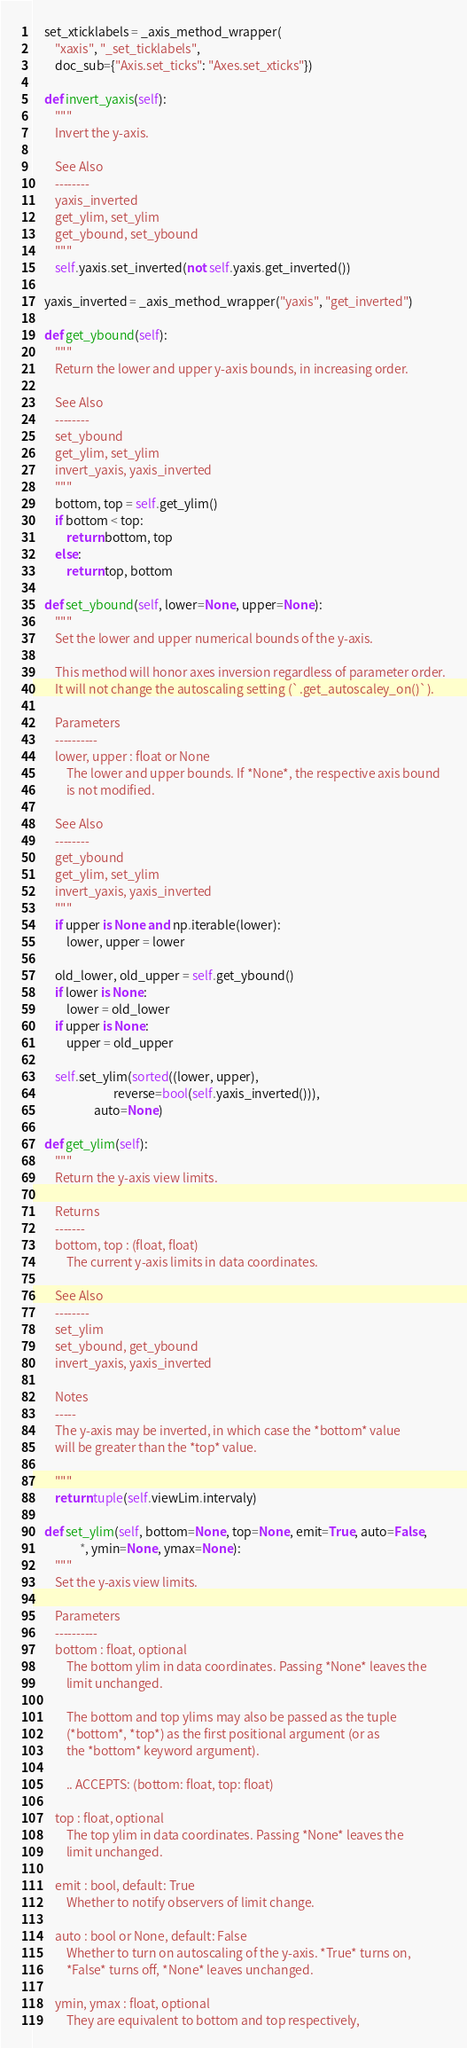<code> <loc_0><loc_0><loc_500><loc_500><_Python_>    set_xticklabels = _axis_method_wrapper(
        "xaxis", "_set_ticklabels",
        doc_sub={"Axis.set_ticks": "Axes.set_xticks"})

    def invert_yaxis(self):
        """
        Invert the y-axis.

        See Also
        --------
        yaxis_inverted
        get_ylim, set_ylim
        get_ybound, set_ybound
        """
        self.yaxis.set_inverted(not self.yaxis.get_inverted())

    yaxis_inverted = _axis_method_wrapper("yaxis", "get_inverted")

    def get_ybound(self):
        """
        Return the lower and upper y-axis bounds, in increasing order.

        See Also
        --------
        set_ybound
        get_ylim, set_ylim
        invert_yaxis, yaxis_inverted
        """
        bottom, top = self.get_ylim()
        if bottom < top:
            return bottom, top
        else:
            return top, bottom

    def set_ybound(self, lower=None, upper=None):
        """
        Set the lower and upper numerical bounds of the y-axis.

        This method will honor axes inversion regardless of parameter order.
        It will not change the autoscaling setting (`.get_autoscaley_on()`).

        Parameters
        ----------
        lower, upper : float or None
            The lower and upper bounds. If *None*, the respective axis bound
            is not modified.

        See Also
        --------
        get_ybound
        get_ylim, set_ylim
        invert_yaxis, yaxis_inverted
        """
        if upper is None and np.iterable(lower):
            lower, upper = lower

        old_lower, old_upper = self.get_ybound()
        if lower is None:
            lower = old_lower
        if upper is None:
            upper = old_upper

        self.set_ylim(sorted((lower, upper),
                             reverse=bool(self.yaxis_inverted())),
                      auto=None)

    def get_ylim(self):
        """
        Return the y-axis view limits.

        Returns
        -------
        bottom, top : (float, float)
            The current y-axis limits in data coordinates.

        See Also
        --------
        set_ylim
        set_ybound, get_ybound
        invert_yaxis, yaxis_inverted

        Notes
        -----
        The y-axis may be inverted, in which case the *bottom* value
        will be greater than the *top* value.

        """
        return tuple(self.viewLim.intervaly)

    def set_ylim(self, bottom=None, top=None, emit=True, auto=False,
                 *, ymin=None, ymax=None):
        """
        Set the y-axis view limits.

        Parameters
        ----------
        bottom : float, optional
            The bottom ylim in data coordinates. Passing *None* leaves the
            limit unchanged.

            The bottom and top ylims may also be passed as the tuple
            (*bottom*, *top*) as the first positional argument (or as
            the *bottom* keyword argument).

            .. ACCEPTS: (bottom: float, top: float)

        top : float, optional
            The top ylim in data coordinates. Passing *None* leaves the
            limit unchanged.

        emit : bool, default: True
            Whether to notify observers of limit change.

        auto : bool or None, default: False
            Whether to turn on autoscaling of the y-axis. *True* turns on,
            *False* turns off, *None* leaves unchanged.

        ymin, ymax : float, optional
            They are equivalent to bottom and top respectively,</code> 